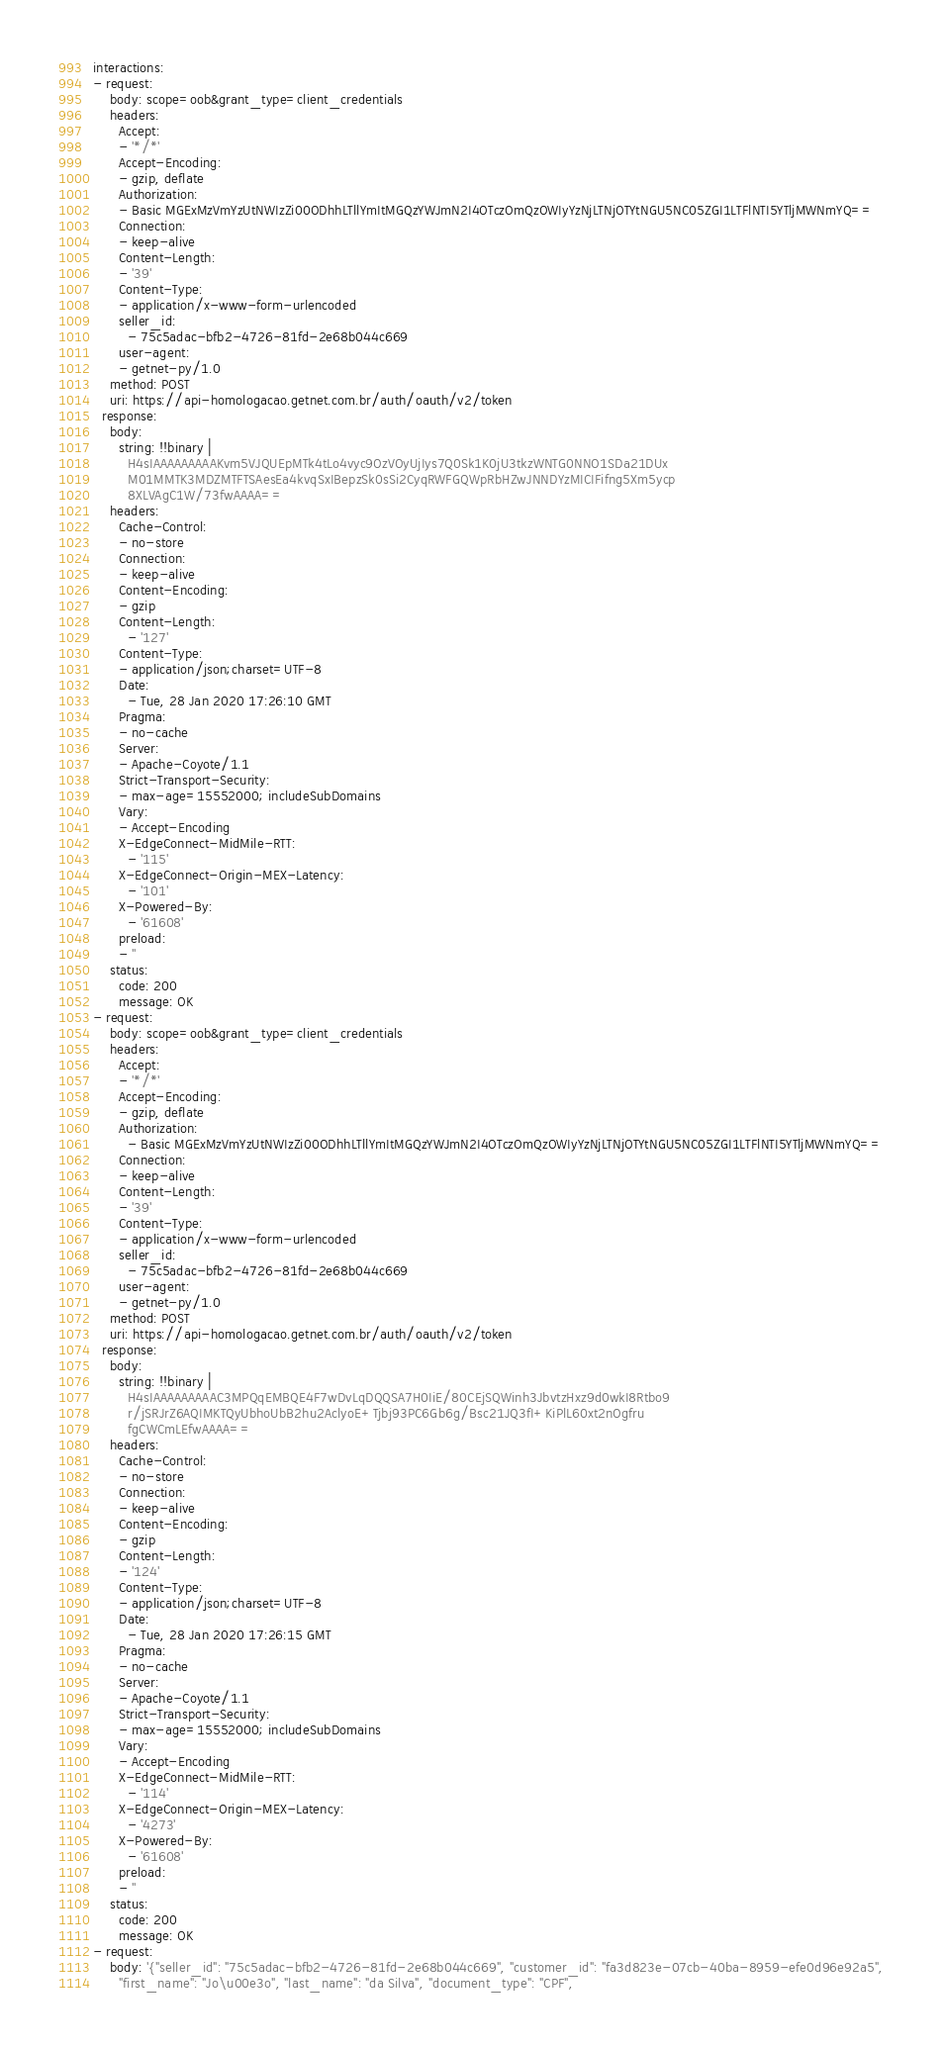Convert code to text. <code><loc_0><loc_0><loc_500><loc_500><_YAML_>interactions:
- request:
    body: scope=oob&grant_type=client_credentials
    headers:
      Accept:
      - '*/*'
      Accept-Encoding:
      - gzip, deflate
      Authorization:
      - Basic MGExMzVmYzUtNWIzZi00ODhhLTllYmItMGQzYWJmN2I4OTczOmQzOWIyYzNjLTNjOTYtNGU5NC05ZGI1LTFlNTI5YTljMWNmYQ==
      Connection:
      - keep-alive
      Content-Length:
      - '39'
      Content-Type:
      - application/x-www-form-urlencoded
      seller_id:
        - 75c5adac-bfb2-4726-81fd-2e68b044c669
      user-agent:
      - getnet-py/1.0
    method: POST
    uri: https://api-homologacao.getnet.com.br/auth/oauth/v2/token
  response:
    body:
      string: !!binary |
        H4sIAAAAAAAAAKvm5VJQUEpMTk4tLo4vyc9OzVOyUjIys7Q0Sk1K0jU3tkzWNTG0NNO1SDa21DUx
        M01MMTK3MDZMTFTSAesEa4kvqSxIBepzSk0sSi2CyqRWFGQWpRbHZwJNNDYzMICIFifng5Xm5ycp
        8XLVAgC1W/73fwAAAA==
    headers:
      Cache-Control:
      - no-store
      Connection:
      - keep-alive
      Content-Encoding:
      - gzip
      Content-Length:
        - '127'
      Content-Type:
      - application/json;charset=UTF-8
      Date:
        - Tue, 28 Jan 2020 17:26:10 GMT
      Pragma:
      - no-cache
      Server:
      - Apache-Coyote/1.1
      Strict-Transport-Security:
      - max-age=15552000; includeSubDomains
      Vary:
      - Accept-Encoding
      X-EdgeConnect-MidMile-RTT:
        - '115'
      X-EdgeConnect-Origin-MEX-Latency:
        - '101'
      X-Powered-By:
        - '61608'
      preload:
      - ''
    status:
      code: 200
      message: OK
- request:
    body: scope=oob&grant_type=client_credentials
    headers:
      Accept:
      - '*/*'
      Accept-Encoding:
      - gzip, deflate
      Authorization:
        - Basic MGExMzVmYzUtNWIzZi00ODhhLTllYmItMGQzYWJmN2I4OTczOmQzOWIyYzNjLTNjOTYtNGU5NC05ZGI1LTFlNTI5YTljMWNmYQ==
      Connection:
      - keep-alive
      Content-Length:
      - '39'
      Content-Type:
      - application/x-www-form-urlencoded
      seller_id:
        - 75c5adac-bfb2-4726-81fd-2e68b044c669
      user-agent:
      - getnet-py/1.0
    method: POST
    uri: https://api-homologacao.getnet.com.br/auth/oauth/v2/token
  response:
    body:
      string: !!binary |
        H4sIAAAAAAAAAC3MPQqEMBQE4F7wDvLqDQQSA7H0IiE/80CEjSQWinh3JbvtzHxz9d0wkI8Rtbo9
        r/jSRJrZ6AQIMKTQyUbhoUbB2hu2AclyoE+Tjbj93PC6Gb6g/Bsc21JQ3fI+KiPlL60xt2nOgfru
        fgCWCmLEfwAAAA==
    headers:
      Cache-Control:
      - no-store
      Connection:
      - keep-alive
      Content-Encoding:
      - gzip
      Content-Length:
      - '124'
      Content-Type:
      - application/json;charset=UTF-8
      Date:
        - Tue, 28 Jan 2020 17:26:15 GMT
      Pragma:
      - no-cache
      Server:
      - Apache-Coyote/1.1
      Strict-Transport-Security:
      - max-age=15552000; includeSubDomains
      Vary:
      - Accept-Encoding
      X-EdgeConnect-MidMile-RTT:
        - '114'
      X-EdgeConnect-Origin-MEX-Latency:
        - '4273'
      X-Powered-By:
        - '61608'
      preload:
      - ''
    status:
      code: 200
      message: OK
- request:
    body: '{"seller_id": "75c5adac-bfb2-4726-81fd-2e68b044c669", "customer_id": "fa3d823e-07cb-40ba-8959-efe0d96e92a5",
      "first_name": "Jo\u00e3o", "last_name": "da Silva", "document_type": "CPF",</code> 